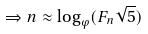<formula> <loc_0><loc_0><loc_500><loc_500>\Rightarrow n \approx \log _ { \varphi } ( F _ { n } \sqrt { 5 } )</formula> 